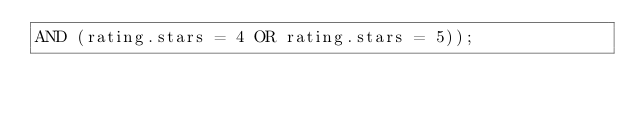<code> <loc_0><loc_0><loc_500><loc_500><_SQL_>AND (rating.stars = 4 OR rating.stars = 5));
</code> 